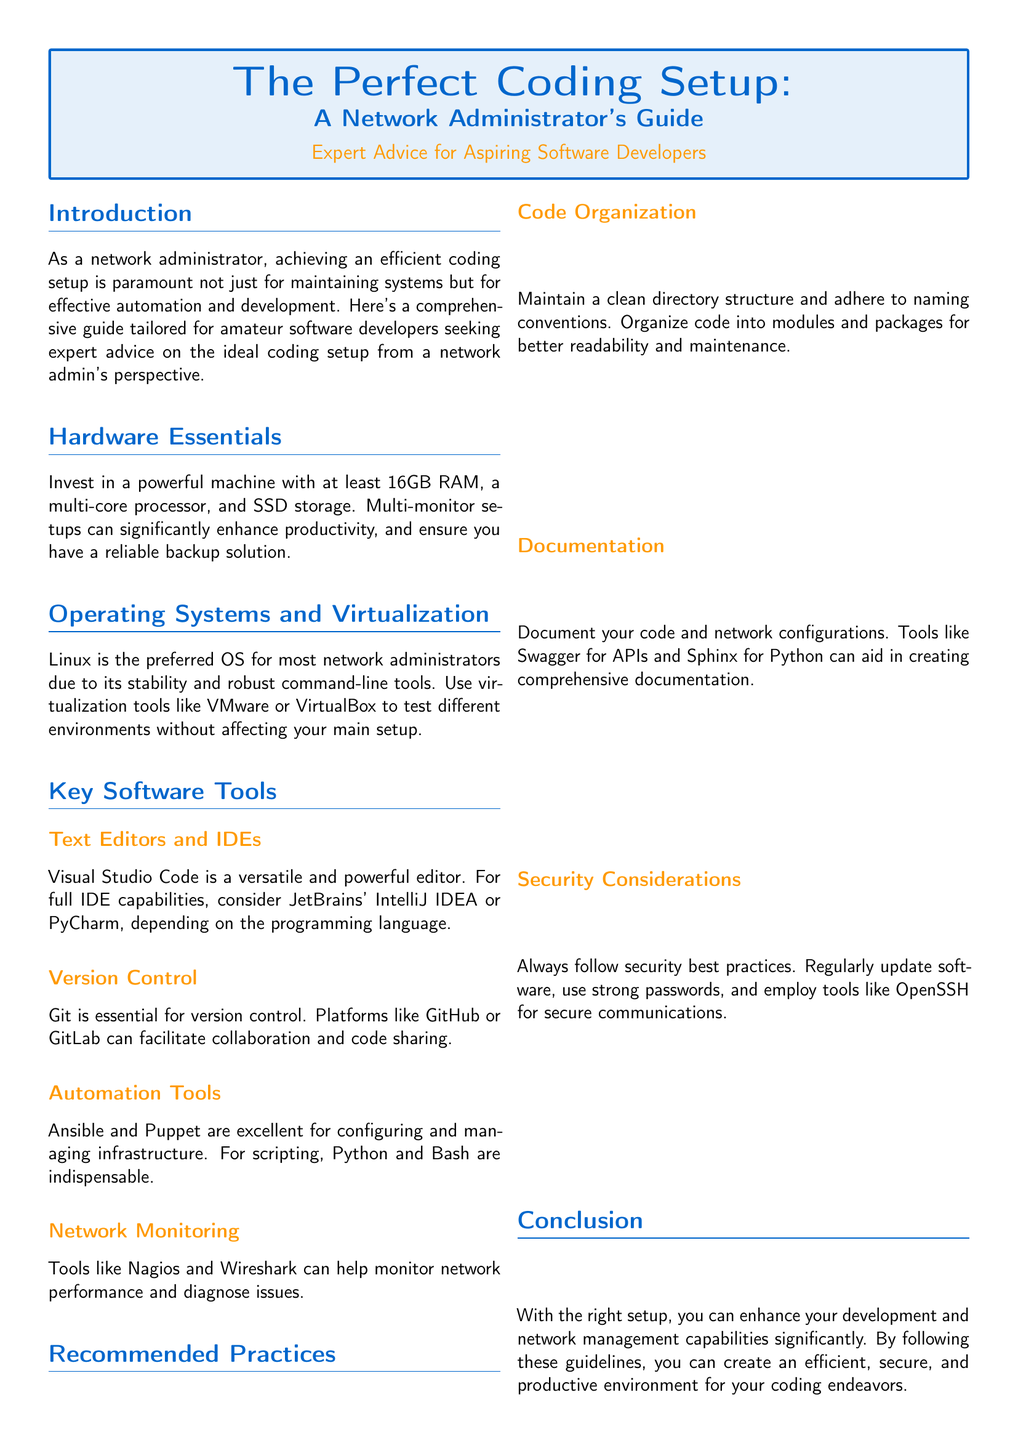What is the recommended RAM for a powerful machine? The document states that a powerful machine should have at least 16GB RAM.
Answer: 16GB RAM Which operating system is preferred by network administrators? According to the document, Linux is the preferred OS for most network administrators due to its stability.
Answer: Linux Name one recommended tool for network monitoring. The document lists Nagios and Wireshark as network monitoring tools.
Answer: Nagios What is the Tool of the Month featured in the document? The document highlights Visual Studio Code as the Tool of the Month.
Answer: Visual Studio Code What is one automation tool mentioned in the document? The document mentions Ansible and Puppet as excellent automation tools.
Answer: Ansible What should you maintain for better code readability? The document emphasizes the importance of a clean directory structure and naming conventions.
Answer: Clean directory structure Which software is suggested for API documentation? Swagger is mentioned in the document as a tool for creating API documentation.
Answer: Swagger 